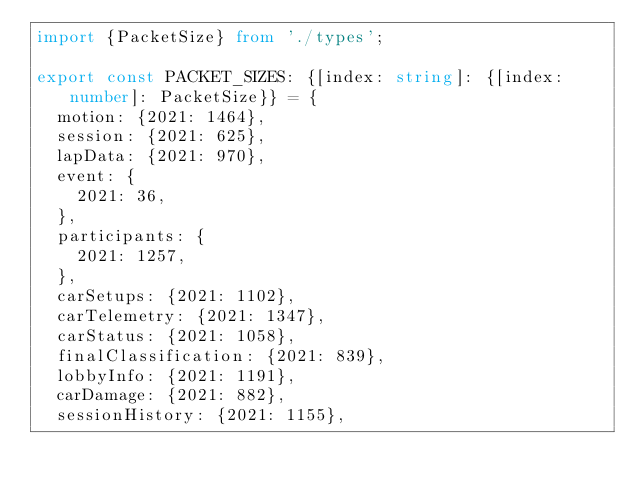<code> <loc_0><loc_0><loc_500><loc_500><_TypeScript_>import {PacketSize} from './types';

export const PACKET_SIZES: {[index: string]: {[index: number]: PacketSize}} = {
  motion: {2021: 1464},
  session: {2021: 625},
  lapData: {2021: 970},
  event: {
    2021: 36,
  },
  participants: {
    2021: 1257,
  },
  carSetups: {2021: 1102},
  carTelemetry: {2021: 1347},
  carStatus: {2021: 1058},
  finalClassification: {2021: 839},
  lobbyInfo: {2021: 1191},
  carDamage: {2021: 882},
  sessionHistory: {2021: 1155},
</code> 